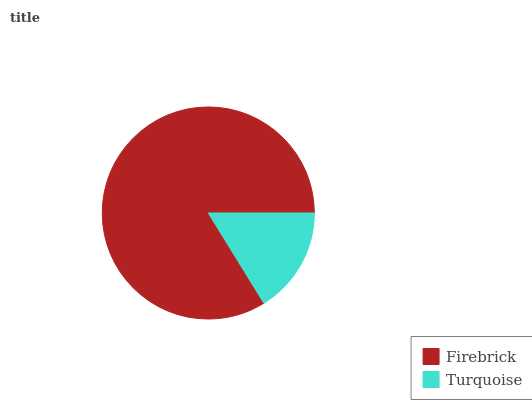Is Turquoise the minimum?
Answer yes or no. Yes. Is Firebrick the maximum?
Answer yes or no. Yes. Is Turquoise the maximum?
Answer yes or no. No. Is Firebrick greater than Turquoise?
Answer yes or no. Yes. Is Turquoise less than Firebrick?
Answer yes or no. Yes. Is Turquoise greater than Firebrick?
Answer yes or no. No. Is Firebrick less than Turquoise?
Answer yes or no. No. Is Firebrick the high median?
Answer yes or no. Yes. Is Turquoise the low median?
Answer yes or no. Yes. Is Turquoise the high median?
Answer yes or no. No. Is Firebrick the low median?
Answer yes or no. No. 